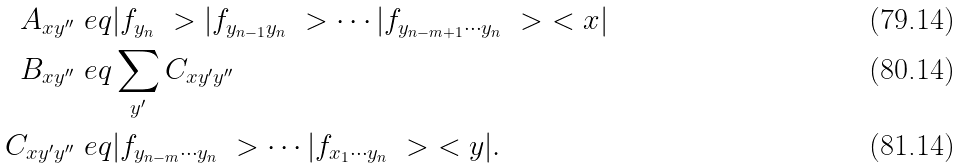Convert formula to latex. <formula><loc_0><loc_0><loc_500><loc_500>A _ { x y ^ { \prime \prime } } & \ e q | f _ { y _ { n } } \ > | f _ { y _ { n - 1 } y _ { n } } \ > \cdots | f _ { y _ { n - m + 1 } \cdots y _ { n } } \ > \ < x | \\ B _ { x y ^ { \prime \prime } } & \ e q \sum _ { y ^ { \prime } } C _ { x y ^ { \prime } y ^ { \prime \prime } } \\ C _ { x y ^ { \prime } y ^ { \prime \prime } } & \ e q | f _ { y _ { n - m } \cdots y _ { n } } \ > \cdots | f _ { x _ { 1 } \cdots y _ { n } } \ > \ < y | .</formula> 